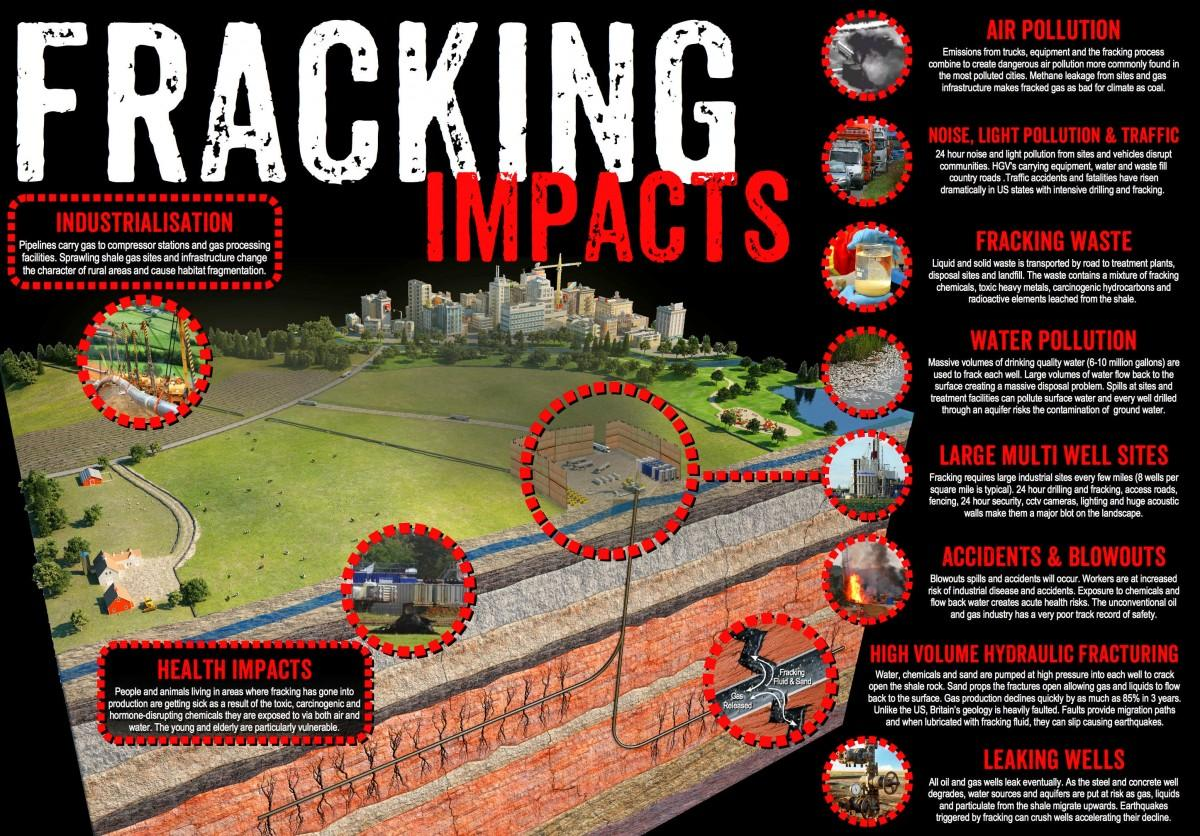Outline some significant characteristics in this image. Fracking is known to cause four types of pollution. 